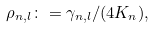<formula> <loc_0><loc_0><loc_500><loc_500>\rho _ { n , l } \colon = \gamma _ { n , l } / ( 4 K _ { n } ) ,</formula> 